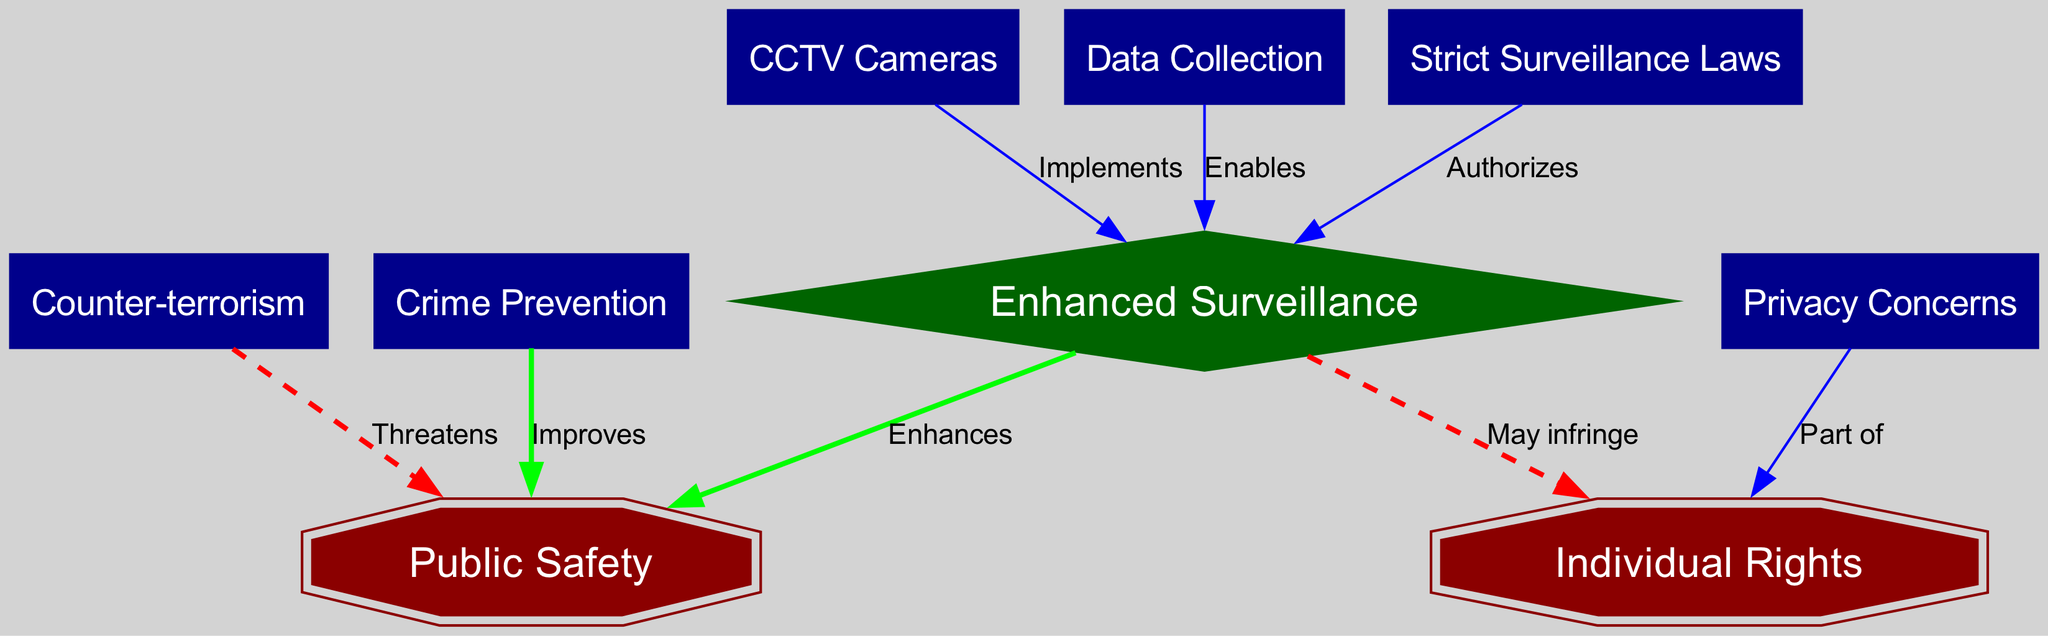What is the central theme of the diagram? The central theme is "Balancing public safety and individual rights in surveillance policies," which connects various aspects of surveillance and its impact.
Answer: Balancing public safety and individual rights in surveillance policies How many nodes are in the diagram? Counting all the unique entities in the diagram reveals there are eight nodes, representing different aspects of surveillance and its implications.
Answer: Eight What relationship does "data collection" have with "enhanced surveillance"? The diagram shows that "data collection" enables "enhanced surveillance," indicating that data gathering supports surveillance measures.
Answer: Enables What are the two key focuses of this concept map? The diagram highlights "public safety" and "individual rights" as the main focal points, showing the tension between these two elements in the context of surveillance.
Answer: Public safety and individual rights How does "terrorism" affect "public safety"? The relationship is indicated by the arrow labeled "Threatens," suggesting that terrorism poses a challenge to public safety, necessitating surveillance measures.
Answer: Threatens Which node is associated with both "enhanced surveillance" and "individual rights"? The node "may infringe" is associated with "enhanced surveillance" as it indicates a potential conflict with "individual rights."
Answer: May infringe What type of laws are suggested in relation to "surveillance"? The diagram indicates that "strict surveillance laws" are established to authorize and regulate surveillance practices.
Answer: Strict surveillance laws Which node improves public safety according to the diagram? The node "crime prevention" improves public safety as noted in the directed edge labeled "Improves." This suggests a positive relationship between the two.
Answer: Improves What role do "CCTV cameras" play in the context of surveillance? The diagram denotes that "CCTV cameras" implement enhanced surveillance, demonstrating how they contribute to the overall surveillance strategy.
Answer: Implements What is a primary concern associated with individual rights? The node labeled "privacy" serves as a major concern related to individual rights, illustrating the importance of protecting personal privacy in surveillance policies.
Answer: Privacy 